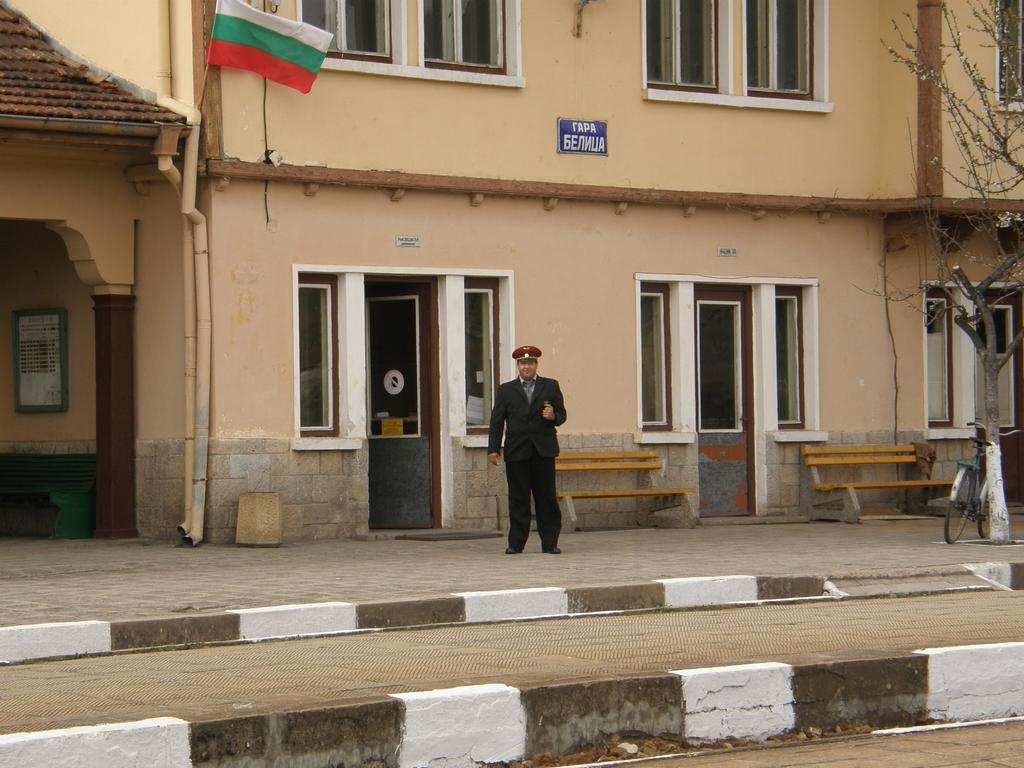In one or two sentences, can you explain what this image depicts? In the picture I can see a man is standing. The man is wearing a hat. In the background I can see a building, a flag, a tree, a bicycle, benches and some other objects. 